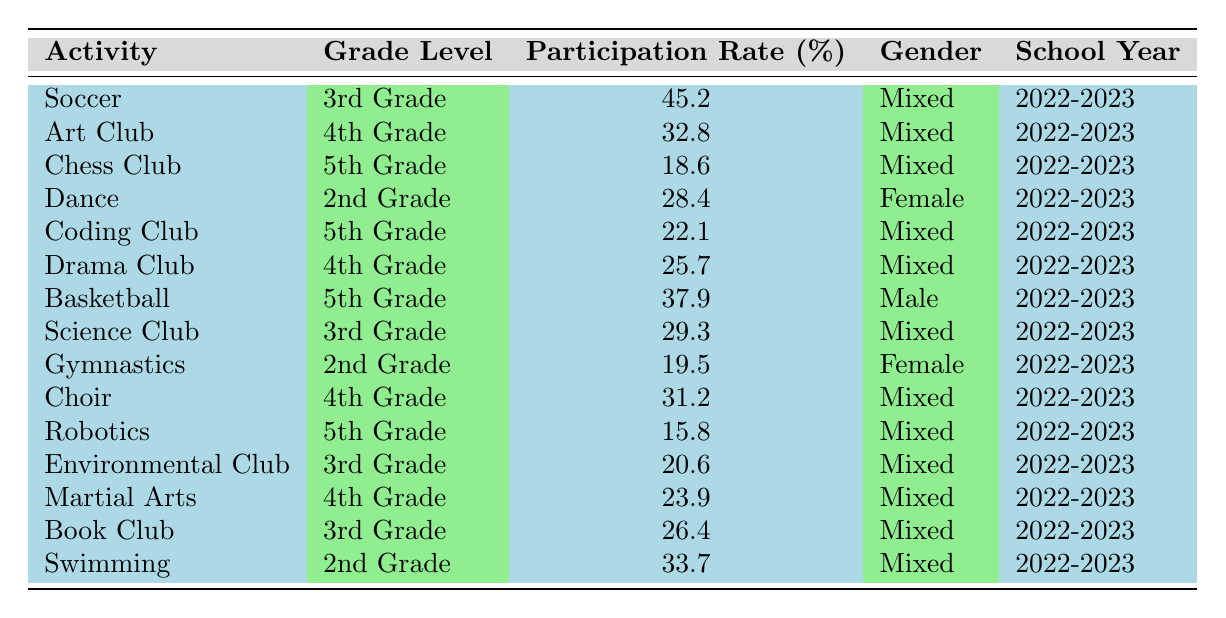What is the participation rate for the Soccer activity? The table shows that the participation rate for Soccer is listed under the corresponding row, where it states Soccer has a rate of 45.2%.
Answer: 45.2% Which extracurricular activity has the highest participation rate? To determine the highest participation rate, we review the Participation Rate column and find that Soccer (45.2%) has the highest value compared to other activities.
Answer: Soccer How many activities have a participation rate of 30% or more? We scan through the Participation Rate column and count the activities with rates of 30% or higher. These activities are Soccer (45.2%), Swimming (33.7%), Art Club (32.8%), Choir (31.2%), and Science Club (29.3%). There are five such activities.
Answer: 5 Is the Dance activity for 2nd grade male students? The table specifies that Dance is categorized under the Female gender, meaning it is primarily for females, thus the answer is no.
Answer: No What is the average participation rate for the 4th Grade activities? We must first identify the participation rates for all 4th Grade activities: Art Club (32.8%), Drama Club (25.7%), Choir (31.2%), and Martial Arts (23.9%). We then sum these rates: (32.8 + 25.7 + 31.2 + 23.9) = 113.6. There are 4 activities, so we calculate the average as 113.6 / 4 = 28.4.
Answer: 28.4 Which grade has the highest total participation rate from the activities listed? We will calculate the total participation rates for each grade level. For 2nd Grade: Dance (28.4%) + Swimming (33.7%) = 62.1%. For 3rd Grade: Soccer (45.2%) + Science Club (29.3%) + Environmental Club (20.6%) + Book Club (26.4%) = 121.5%. For 4th Grade: Art Club (32.8%) + Drama Club (25.7%) + Choir (31.2%) + Martial Arts (23.9%) = 113.6%. For 5th Grade: Chess Club (18.6%) + Coding Club (22.1%) + Basketball (37.9%) + Robotics (15.8%) = 94.4%. The highest total is for 3rd Grade with 121.5%.
Answer: 3rd Grade Are there more mixed-gender activities than female-only activities? The table indicates that there are 10 mixed-gender activities (Soccer, Art Club, Chess Club, Coding Club, Drama Club, Basketball, Science Club, Choir, Robotics, and Martial Arts) and 3 female-only activities (Dance and Gymnastics). Since 10 > 3, the answer is yes.
Answer: Yes What is the participation rate difference between the highest and lowest activity in 5th Grade? The highest participation rate in 5th Grade is Basketball (37.9%), and the lowest is Robotics (15.8%). We find the difference by subtracting the lowest from the highest: 37.9 - 15.8 = 22.1.
Answer: 22.1 